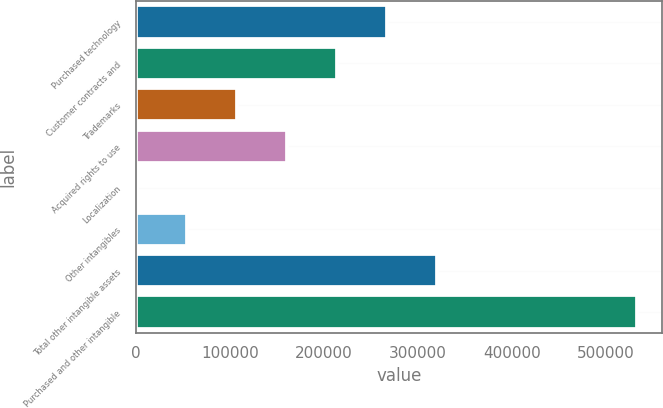Convert chart to OTSL. <chart><loc_0><loc_0><loc_500><loc_500><bar_chart><fcel>Purchased technology<fcel>Customer contracts and<fcel>Trademarks<fcel>Acquired rights to use<fcel>Localization<fcel>Other intangibles<fcel>Total other intangible assets<fcel>Purchased and other intangible<nl><fcel>266369<fcel>213172<fcel>106777<fcel>159974<fcel>382<fcel>53579.4<fcel>319566<fcel>532356<nl></chart> 